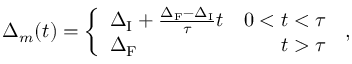<formula> <loc_0><loc_0><loc_500><loc_500>\Delta _ { m } ( t ) = \left \{ \begin{array} { l r } { \Delta _ { I } + \frac { \Delta _ { F } - \Delta _ { I } } { \tau } t } & { 0 < t < \tau } \\ { \Delta _ { F } } & { t > \tau } \end{array} \, ,</formula> 